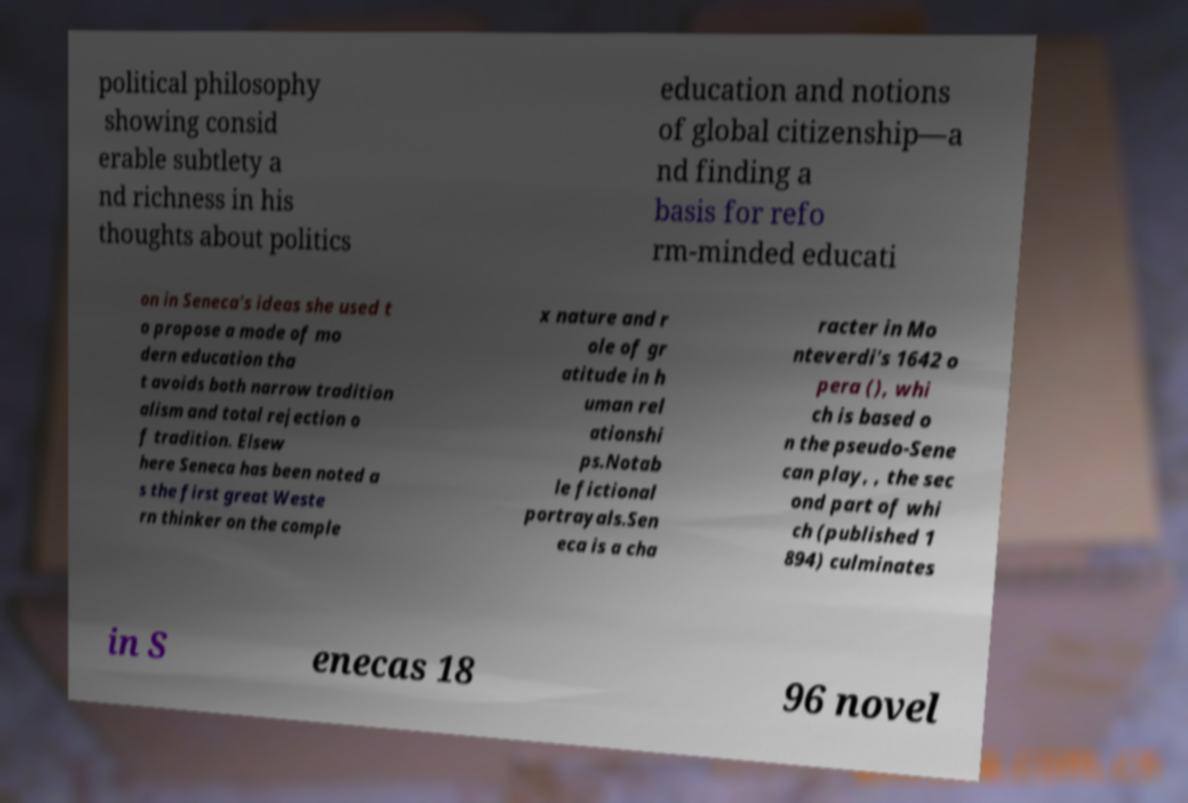I need the written content from this picture converted into text. Can you do that? political philosophy showing consid erable subtlety a nd richness in his thoughts about politics education and notions of global citizenship—a nd finding a basis for refo rm-minded educati on in Seneca's ideas she used t o propose a mode of mo dern education tha t avoids both narrow tradition alism and total rejection o f tradition. Elsew here Seneca has been noted a s the first great Weste rn thinker on the comple x nature and r ole of gr atitude in h uman rel ationshi ps.Notab le fictional portrayals.Sen eca is a cha racter in Mo nteverdi's 1642 o pera (), whi ch is based o n the pseudo-Sene can play, , the sec ond part of whi ch (published 1 894) culminates in S enecas 18 96 novel 